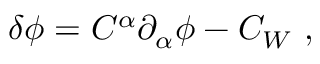Convert formula to latex. <formula><loc_0><loc_0><loc_500><loc_500>\delta \phi = C ^ { \alpha } { \partial } _ { \alpha } \phi - C _ { W } ,</formula> 